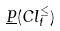Convert formula to latex. <formula><loc_0><loc_0><loc_500><loc_500>\underline { P } ( C l _ { t } ^ { \leq } )</formula> 